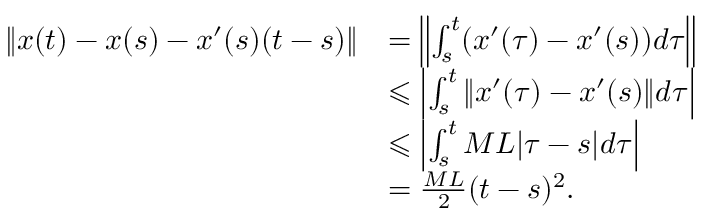<formula> <loc_0><loc_0><loc_500><loc_500>\begin{array} { r l } { \| x ( t ) - x ( s ) - x ^ { \prime } ( s ) ( t - s ) \| } & { = \left \| \int _ { s } ^ { t } ( x ^ { \prime } ( \tau ) - x ^ { \prime } ( s ) ) d \tau \right \| } \\ & { \leqslant \left | \int _ { s } ^ { t } \| x ^ { \prime } ( \tau ) - x ^ { \prime } ( s ) \| d \tau \right | } \\ & { \leqslant \left | \int _ { s } ^ { t } M L | \tau - s | d \tau \right | } \\ & { = \frac { M L } { 2 } ( t - s ) ^ { 2 } . } \end{array}</formula> 